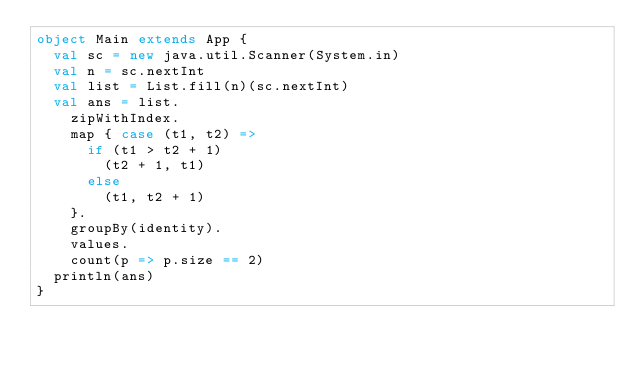Convert code to text. <code><loc_0><loc_0><loc_500><loc_500><_Scala_>object Main extends App {
  val sc = new java.util.Scanner(System.in)
  val n = sc.nextInt
  val list = List.fill(n)(sc.nextInt)
  val ans = list.
    zipWithIndex.
    map { case (t1, t2) =>
      if (t1 > t2 + 1)
        (t2 + 1, t1)
      else
        (t1, t2 + 1)
    }.
    groupBy(identity).
    values.
    count(p => p.size == 2)
  println(ans)
}</code> 